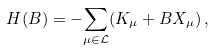Convert formula to latex. <formula><loc_0><loc_0><loc_500><loc_500>H ( B ) = - { \sum _ { \mu \in \mathcal { L } } } ( K _ { \mu } + B X _ { \mu } ) \, ,</formula> 